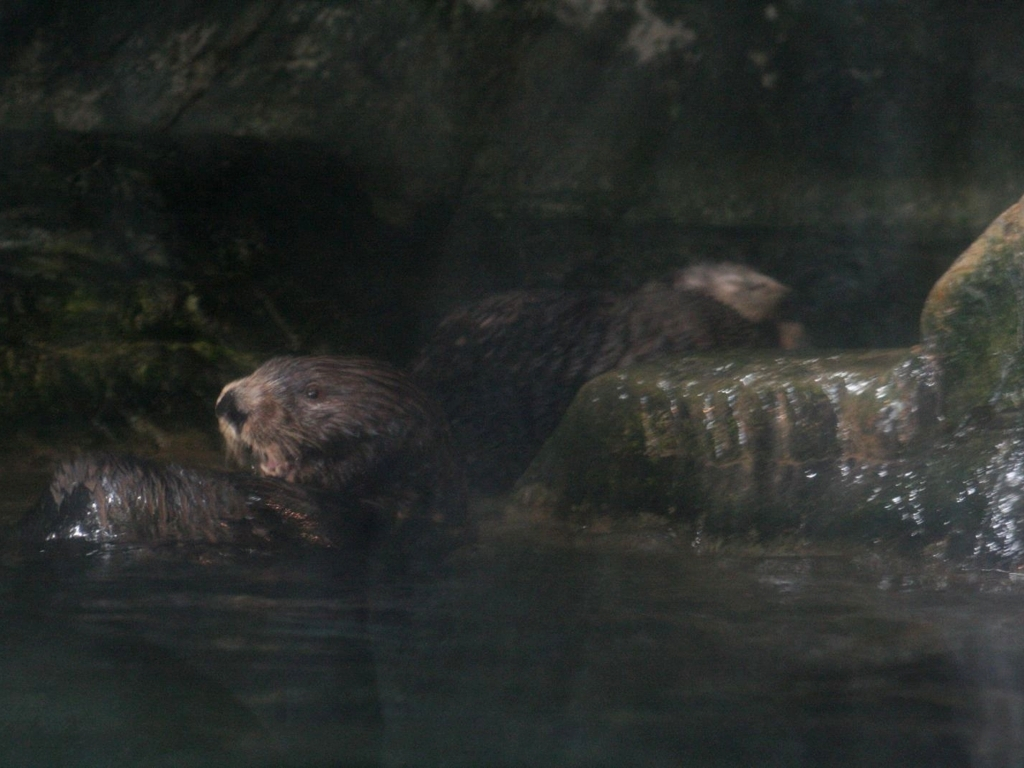What time of day does this image appear to have been taken? Given the low visibility and shadowy areas around the otters, it could either be a low-light condition such as dusk or dawn, or the otters are in a shaded area that is not well-illuminated. 